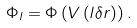Convert formula to latex. <formula><loc_0><loc_0><loc_500><loc_500>\Phi _ { l } = \Phi \left ( V \left ( l \delta r \right ) \right ) .</formula> 